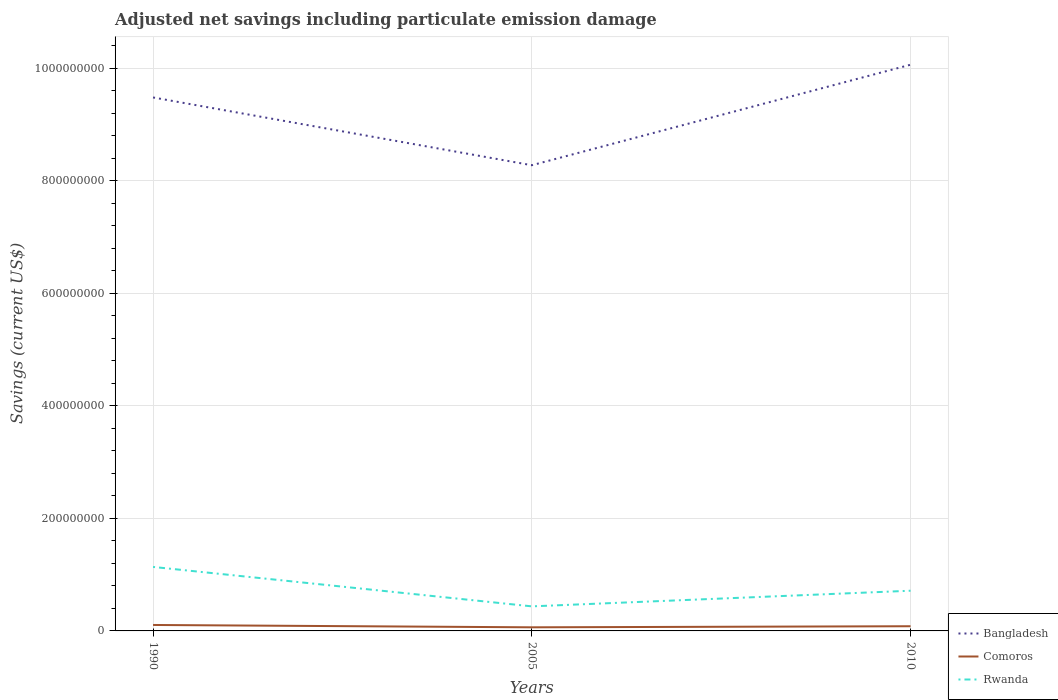How many different coloured lines are there?
Keep it short and to the point. 3. Does the line corresponding to Bangladesh intersect with the line corresponding to Comoros?
Make the answer very short. No. Is the number of lines equal to the number of legend labels?
Provide a succinct answer. Yes. Across all years, what is the maximum net savings in Rwanda?
Ensure brevity in your answer.  4.36e+07. What is the total net savings in Rwanda in the graph?
Provide a succinct answer. -2.78e+07. What is the difference between the highest and the second highest net savings in Comoros?
Provide a succinct answer. 4.16e+06. How many lines are there?
Your response must be concise. 3. Are the values on the major ticks of Y-axis written in scientific E-notation?
Your response must be concise. No. Does the graph contain grids?
Ensure brevity in your answer.  Yes. How many legend labels are there?
Ensure brevity in your answer.  3. What is the title of the graph?
Provide a short and direct response. Adjusted net savings including particulate emission damage. What is the label or title of the X-axis?
Provide a succinct answer. Years. What is the label or title of the Y-axis?
Your response must be concise. Savings (current US$). What is the Savings (current US$) in Bangladesh in 1990?
Make the answer very short. 9.48e+08. What is the Savings (current US$) in Comoros in 1990?
Ensure brevity in your answer.  1.06e+07. What is the Savings (current US$) in Rwanda in 1990?
Ensure brevity in your answer.  1.14e+08. What is the Savings (current US$) in Bangladesh in 2005?
Offer a terse response. 8.27e+08. What is the Savings (current US$) in Comoros in 2005?
Provide a succinct answer. 6.41e+06. What is the Savings (current US$) in Rwanda in 2005?
Make the answer very short. 4.36e+07. What is the Savings (current US$) in Bangladesh in 2010?
Your response must be concise. 1.01e+09. What is the Savings (current US$) of Comoros in 2010?
Your answer should be compact. 8.33e+06. What is the Savings (current US$) in Rwanda in 2010?
Your answer should be compact. 7.14e+07. Across all years, what is the maximum Savings (current US$) of Bangladesh?
Provide a succinct answer. 1.01e+09. Across all years, what is the maximum Savings (current US$) in Comoros?
Provide a short and direct response. 1.06e+07. Across all years, what is the maximum Savings (current US$) of Rwanda?
Your answer should be compact. 1.14e+08. Across all years, what is the minimum Savings (current US$) in Bangladesh?
Keep it short and to the point. 8.27e+08. Across all years, what is the minimum Savings (current US$) of Comoros?
Make the answer very short. 6.41e+06. Across all years, what is the minimum Savings (current US$) of Rwanda?
Ensure brevity in your answer.  4.36e+07. What is the total Savings (current US$) of Bangladesh in the graph?
Provide a succinct answer. 2.78e+09. What is the total Savings (current US$) of Comoros in the graph?
Offer a very short reply. 2.53e+07. What is the total Savings (current US$) in Rwanda in the graph?
Your response must be concise. 2.29e+08. What is the difference between the Savings (current US$) of Bangladesh in 1990 and that in 2005?
Offer a terse response. 1.20e+08. What is the difference between the Savings (current US$) in Comoros in 1990 and that in 2005?
Keep it short and to the point. 4.16e+06. What is the difference between the Savings (current US$) in Rwanda in 1990 and that in 2005?
Provide a short and direct response. 7.01e+07. What is the difference between the Savings (current US$) of Bangladesh in 1990 and that in 2010?
Your answer should be very brief. -5.82e+07. What is the difference between the Savings (current US$) in Comoros in 1990 and that in 2010?
Provide a short and direct response. 2.24e+06. What is the difference between the Savings (current US$) of Rwanda in 1990 and that in 2010?
Your answer should be very brief. 4.23e+07. What is the difference between the Savings (current US$) in Bangladesh in 2005 and that in 2010?
Offer a very short reply. -1.79e+08. What is the difference between the Savings (current US$) in Comoros in 2005 and that in 2010?
Give a very brief answer. -1.92e+06. What is the difference between the Savings (current US$) of Rwanda in 2005 and that in 2010?
Your response must be concise. -2.78e+07. What is the difference between the Savings (current US$) in Bangladesh in 1990 and the Savings (current US$) in Comoros in 2005?
Provide a short and direct response. 9.41e+08. What is the difference between the Savings (current US$) in Bangladesh in 1990 and the Savings (current US$) in Rwanda in 2005?
Provide a succinct answer. 9.04e+08. What is the difference between the Savings (current US$) of Comoros in 1990 and the Savings (current US$) of Rwanda in 2005?
Keep it short and to the point. -3.31e+07. What is the difference between the Savings (current US$) of Bangladesh in 1990 and the Savings (current US$) of Comoros in 2010?
Provide a short and direct response. 9.40e+08. What is the difference between the Savings (current US$) in Bangladesh in 1990 and the Savings (current US$) in Rwanda in 2010?
Offer a very short reply. 8.76e+08. What is the difference between the Savings (current US$) in Comoros in 1990 and the Savings (current US$) in Rwanda in 2010?
Provide a succinct answer. -6.09e+07. What is the difference between the Savings (current US$) in Bangladesh in 2005 and the Savings (current US$) in Comoros in 2010?
Give a very brief answer. 8.19e+08. What is the difference between the Savings (current US$) in Bangladesh in 2005 and the Savings (current US$) in Rwanda in 2010?
Provide a short and direct response. 7.56e+08. What is the difference between the Savings (current US$) of Comoros in 2005 and the Savings (current US$) of Rwanda in 2010?
Your answer should be compact. -6.50e+07. What is the average Savings (current US$) of Bangladesh per year?
Provide a short and direct response. 9.27e+08. What is the average Savings (current US$) in Comoros per year?
Offer a terse response. 8.43e+06. What is the average Savings (current US$) of Rwanda per year?
Make the answer very short. 7.63e+07. In the year 1990, what is the difference between the Savings (current US$) of Bangladesh and Savings (current US$) of Comoros?
Keep it short and to the point. 9.37e+08. In the year 1990, what is the difference between the Savings (current US$) of Bangladesh and Savings (current US$) of Rwanda?
Offer a terse response. 8.34e+08. In the year 1990, what is the difference between the Savings (current US$) in Comoros and Savings (current US$) in Rwanda?
Your answer should be very brief. -1.03e+08. In the year 2005, what is the difference between the Savings (current US$) in Bangladesh and Savings (current US$) in Comoros?
Provide a short and direct response. 8.21e+08. In the year 2005, what is the difference between the Savings (current US$) in Bangladesh and Savings (current US$) in Rwanda?
Offer a very short reply. 7.84e+08. In the year 2005, what is the difference between the Savings (current US$) of Comoros and Savings (current US$) of Rwanda?
Provide a succinct answer. -3.72e+07. In the year 2010, what is the difference between the Savings (current US$) of Bangladesh and Savings (current US$) of Comoros?
Offer a very short reply. 9.98e+08. In the year 2010, what is the difference between the Savings (current US$) of Bangladesh and Savings (current US$) of Rwanda?
Offer a very short reply. 9.35e+08. In the year 2010, what is the difference between the Savings (current US$) in Comoros and Savings (current US$) in Rwanda?
Your answer should be very brief. -6.31e+07. What is the ratio of the Savings (current US$) in Bangladesh in 1990 to that in 2005?
Ensure brevity in your answer.  1.15. What is the ratio of the Savings (current US$) in Comoros in 1990 to that in 2005?
Your response must be concise. 1.65. What is the ratio of the Savings (current US$) of Rwanda in 1990 to that in 2005?
Keep it short and to the point. 2.61. What is the ratio of the Savings (current US$) in Bangladesh in 1990 to that in 2010?
Provide a short and direct response. 0.94. What is the ratio of the Savings (current US$) in Comoros in 1990 to that in 2010?
Keep it short and to the point. 1.27. What is the ratio of the Savings (current US$) of Rwanda in 1990 to that in 2010?
Provide a succinct answer. 1.59. What is the ratio of the Savings (current US$) in Bangladesh in 2005 to that in 2010?
Ensure brevity in your answer.  0.82. What is the ratio of the Savings (current US$) of Comoros in 2005 to that in 2010?
Your answer should be compact. 0.77. What is the ratio of the Savings (current US$) in Rwanda in 2005 to that in 2010?
Offer a terse response. 0.61. What is the difference between the highest and the second highest Savings (current US$) in Bangladesh?
Your answer should be compact. 5.82e+07. What is the difference between the highest and the second highest Savings (current US$) of Comoros?
Provide a succinct answer. 2.24e+06. What is the difference between the highest and the second highest Savings (current US$) of Rwanda?
Keep it short and to the point. 4.23e+07. What is the difference between the highest and the lowest Savings (current US$) in Bangladesh?
Make the answer very short. 1.79e+08. What is the difference between the highest and the lowest Savings (current US$) in Comoros?
Make the answer very short. 4.16e+06. What is the difference between the highest and the lowest Savings (current US$) of Rwanda?
Provide a succinct answer. 7.01e+07. 